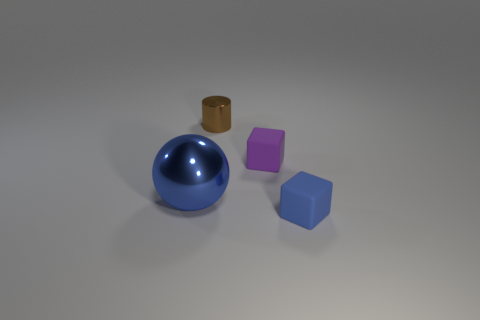Add 1 tiny purple shiny things. How many objects exist? 5 Subtract all purple cubes. How many cubes are left? 1 Subtract all balls. How many objects are left? 3 Subtract 1 blocks. How many blocks are left? 1 Subtract all purple balls. How many purple blocks are left? 1 Subtract all big cyan metallic balls. Subtract all metallic balls. How many objects are left? 3 Add 2 metallic cylinders. How many metallic cylinders are left? 3 Add 2 yellow spheres. How many yellow spheres exist? 2 Subtract 0 blue cylinders. How many objects are left? 4 Subtract all green cubes. Subtract all yellow spheres. How many cubes are left? 2 